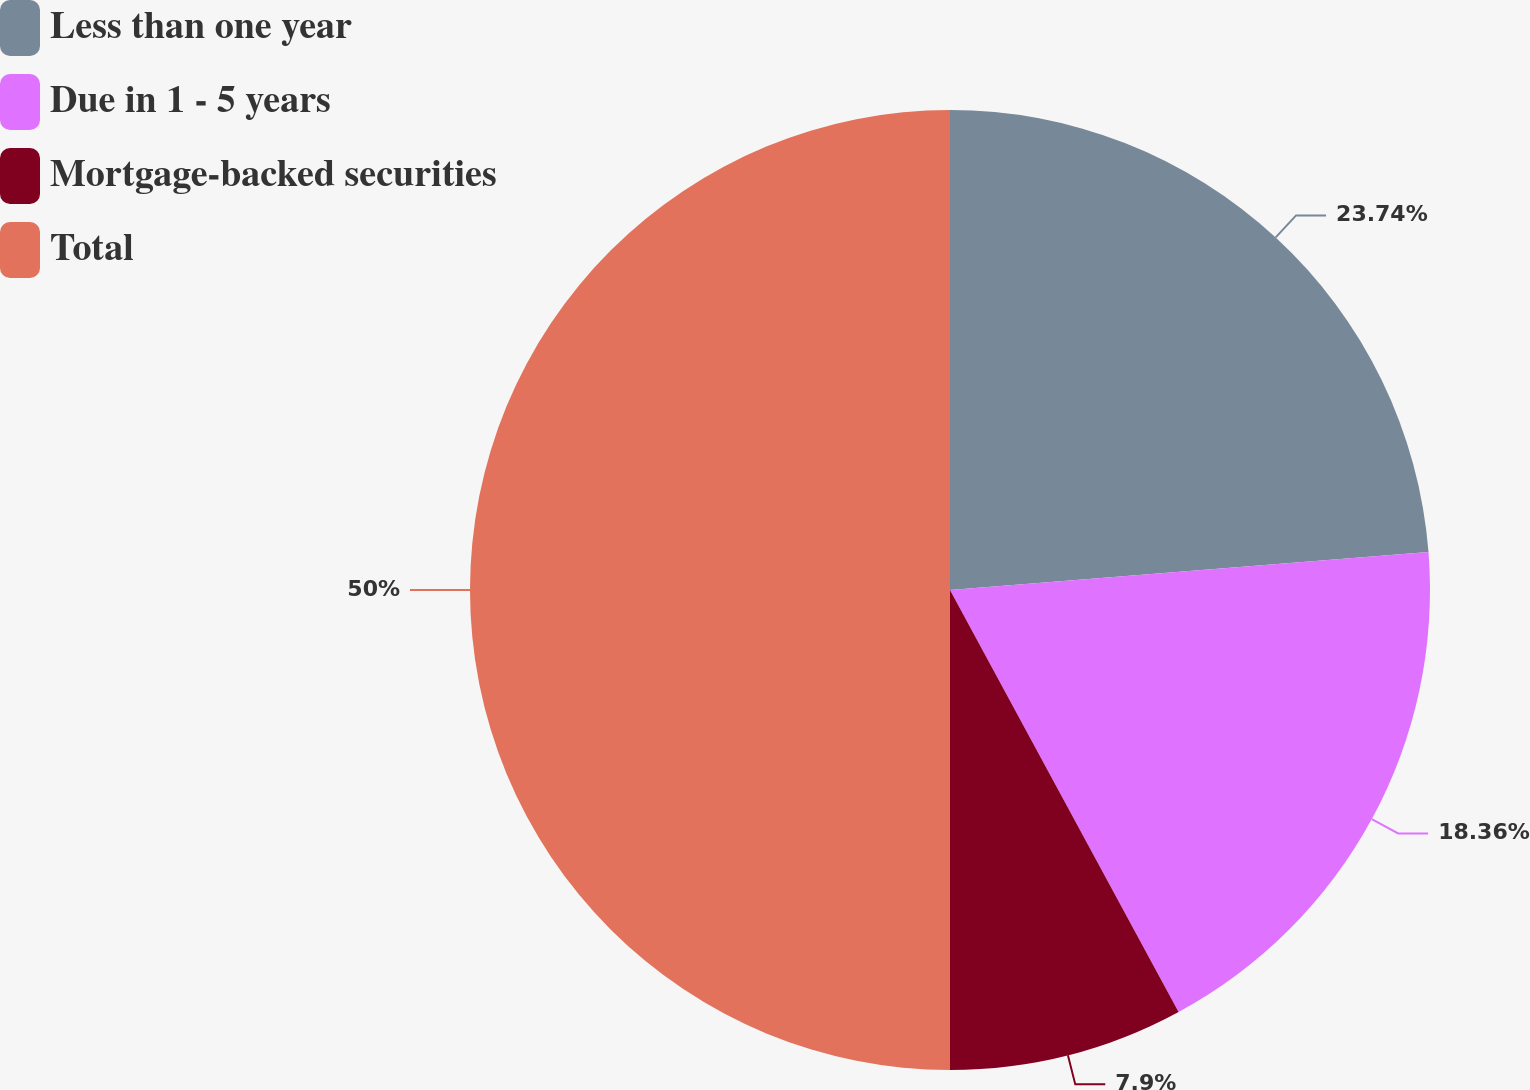Convert chart to OTSL. <chart><loc_0><loc_0><loc_500><loc_500><pie_chart><fcel>Less than one year<fcel>Due in 1 - 5 years<fcel>Mortgage-backed securities<fcel>Total<nl><fcel>23.74%<fcel>18.36%<fcel>7.9%<fcel>50.0%<nl></chart> 